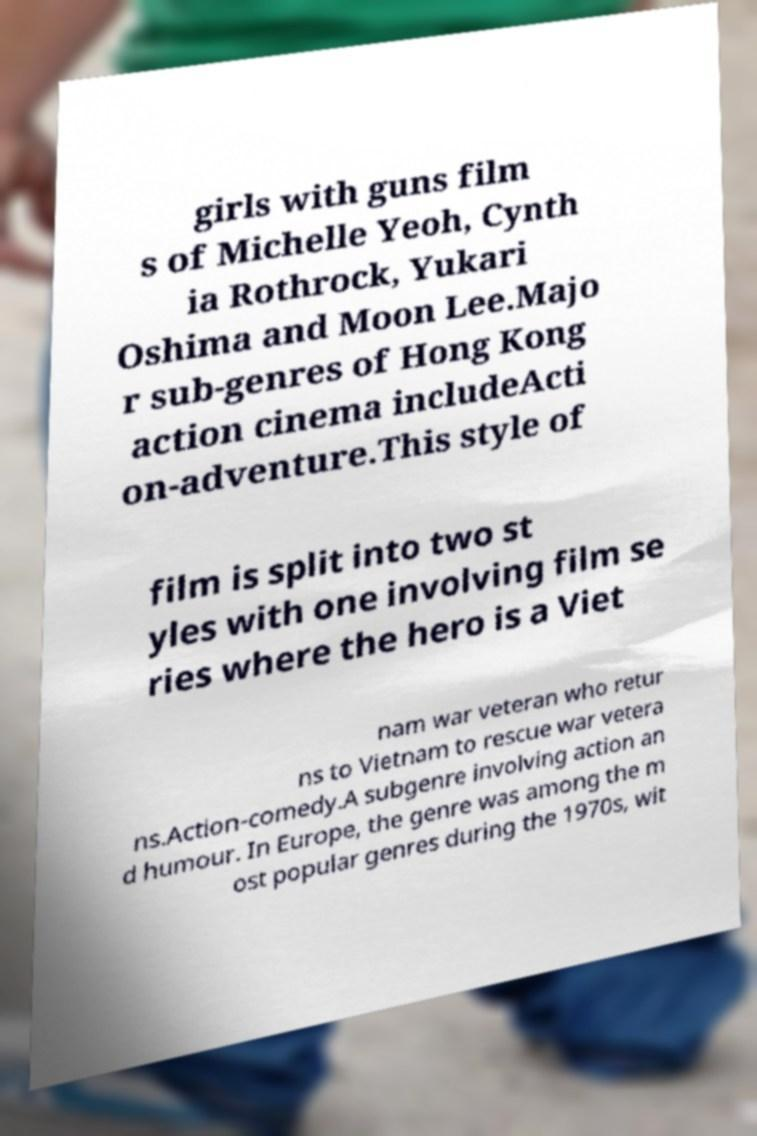Could you assist in decoding the text presented in this image and type it out clearly? girls with guns film s of Michelle Yeoh, Cynth ia Rothrock, Yukari Oshima and Moon Lee.Majo r sub-genres of Hong Kong action cinema includeActi on-adventure.This style of film is split into two st yles with one involving film se ries where the hero is a Viet nam war veteran who retur ns to Vietnam to rescue war vetera ns.Action-comedy.A subgenre involving action an d humour. In Europe, the genre was among the m ost popular genres during the 1970s, wit 